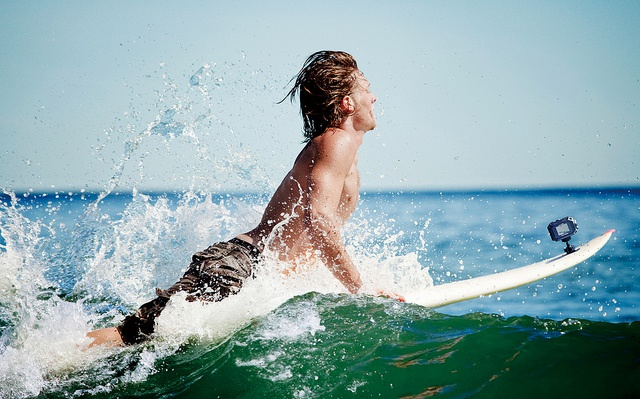Describe the objects in this image and their specific colors. I can see people in lightblue, black, tan, lightgray, and maroon tones and surfboard in lightblue, white, teal, and darkgray tones in this image. 